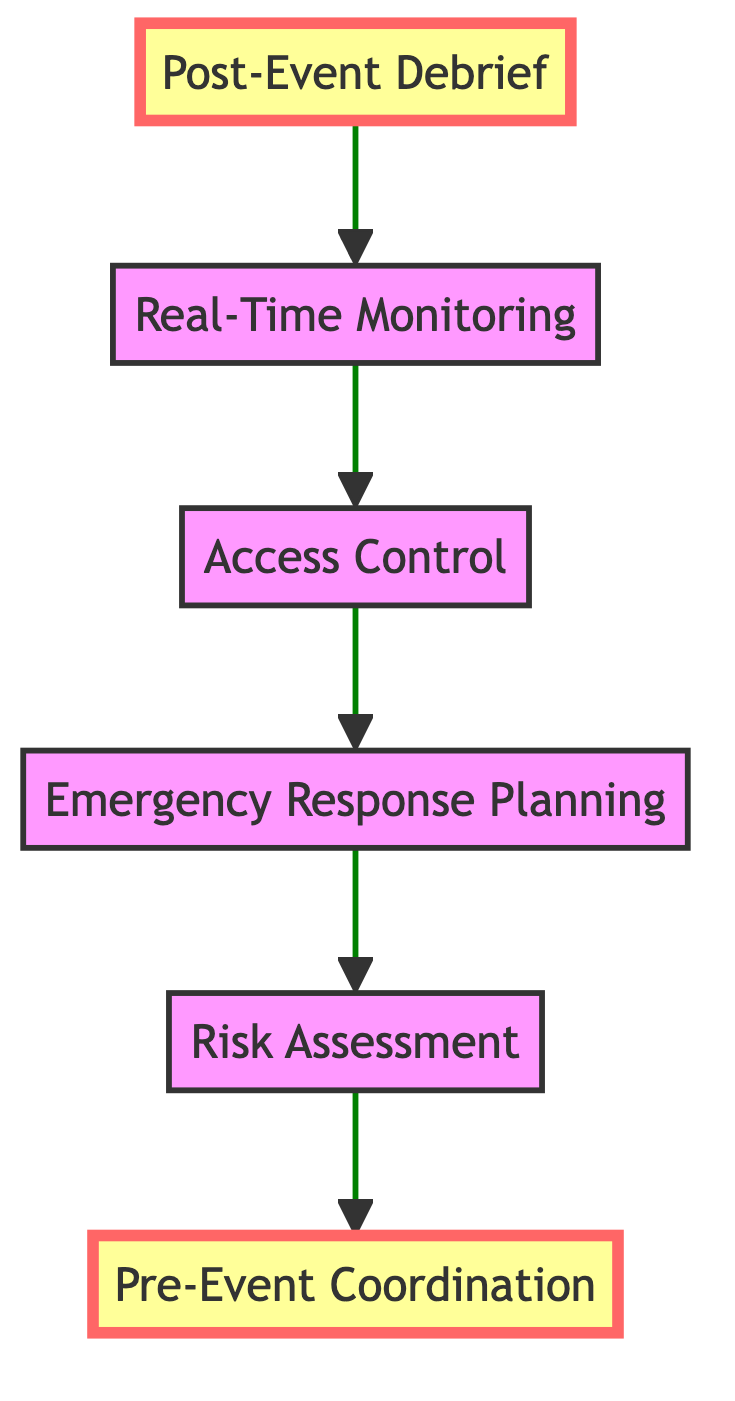What is the final step in the security protocol flow? The flowchart illustrates a sequence of steps moving from bottom to top, and the final step is "Post-Event Debrief" which is found at the bottom of the flow.
Answer: Post-Event Debrief How many nodes are present in the flowchart? By counting the distinct steps represented in the flowchart, there are six nodes including "Pre-Event Coordination", "Risk Assessment", "Emergency Response Planning", "Access Control", "Real-Time Monitoring", and "Post-Event Debrief".
Answer: Six What describes "Access Control"? In the flowchart, each node includes a description, and "Access Control" is defined as the implementation of multi-layered security checks including RSVP verification, metal detectors, and bag inspections.
Answer: Implementation of multi-layered security checks Which two steps are directly sequential? In the flowchart, "Real-Time Monitoring" directly follows "Access Control", indicating that once access is controlled, real-time monitoring occurs next.
Answer: Real-Time Monitoring and Access Control What preparation occurs before any event? The diagram starts with "Pre-Event Coordination", indicating this is the first and foundational step that takes place to prepare security arrangements before the actual event.
Answer: Pre-Event Coordination What is the relationship between "Emergency Response Planning" and "Real-Time Monitoring"? In the flowchart, "Emergency Response Planning" flows into "Real-Time Monitoring", showing that emergency planning is conducted prior to active monitoring of the event.
Answer: Emergency Response Planning leads to Real-Time Monitoring How many layers of security checks are implemented in "Access Control"? Although the exact number isn’t stated, the description indicates a multi-layered approach, implying two or more distinct layers of checks such as RSVP verification, metal detectors, and bag inspections.
Answer: Multi-layered What occurs after "Real-Time Monitoring"? Following the flow from "Real-Time Monitoring", the next step is "Post-Event Debrief", indicating that monitoring leads to a review after the event has concluded.
Answer: Post-Event Debrief 